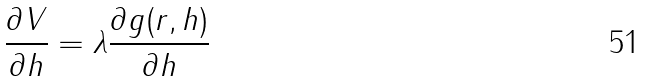Convert formula to latex. <formula><loc_0><loc_0><loc_500><loc_500>\frac { \partial V } { \partial h } = \lambda \frac { \partial g ( r , h ) } { \partial h }</formula> 